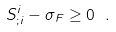<formula> <loc_0><loc_0><loc_500><loc_500>S ^ { i } _ { ; i } - \sigma _ { F } \geq 0 \ .</formula> 